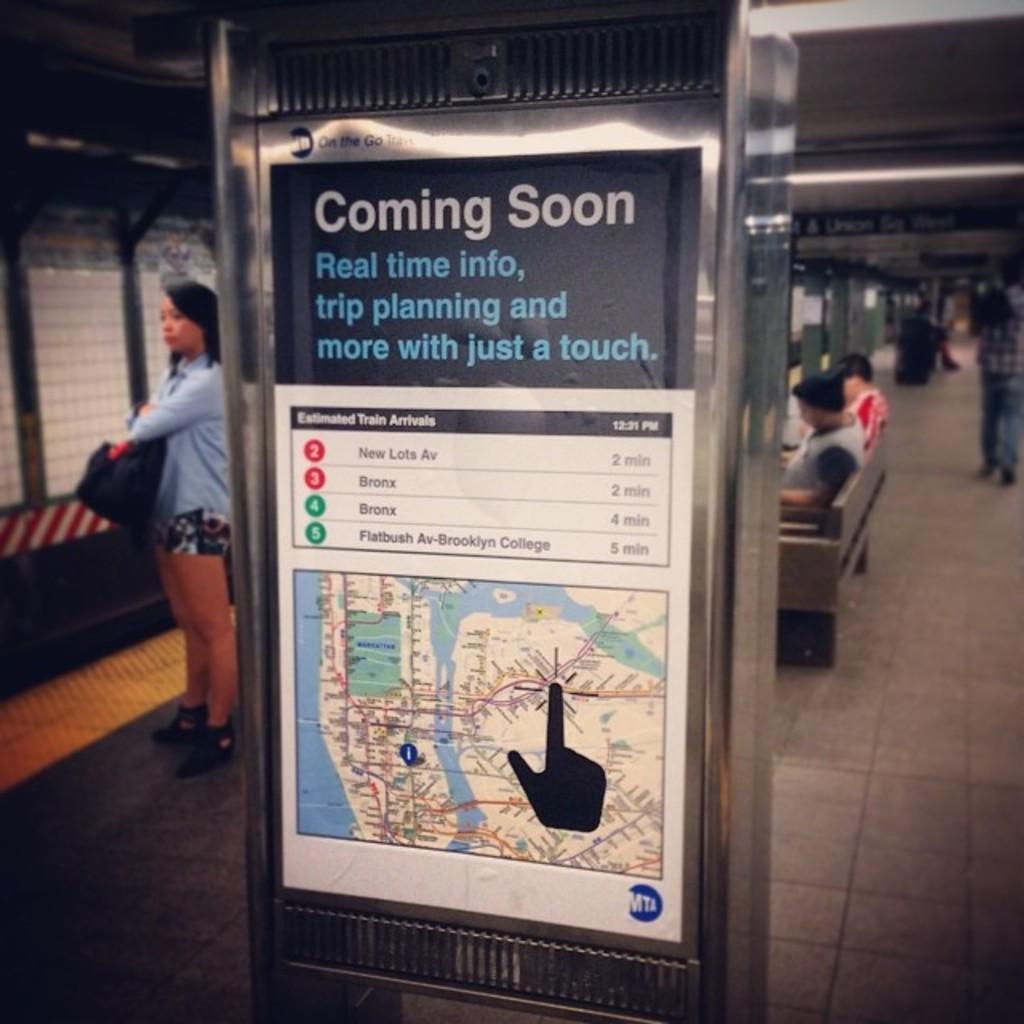What is coming soon?
Give a very brief answer. Real time info, trip planning and more with just a touch. Who made this poster?
Your response must be concise. Mta. 